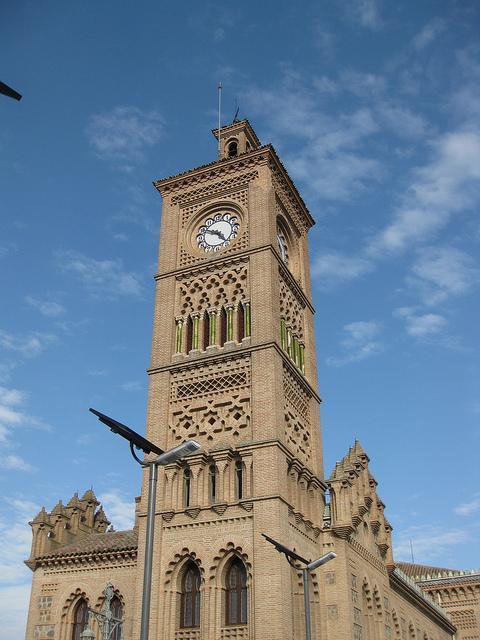How many clocks are visible?
Give a very brief answer. 2. How many towers are there?
Give a very brief answer. 1. 